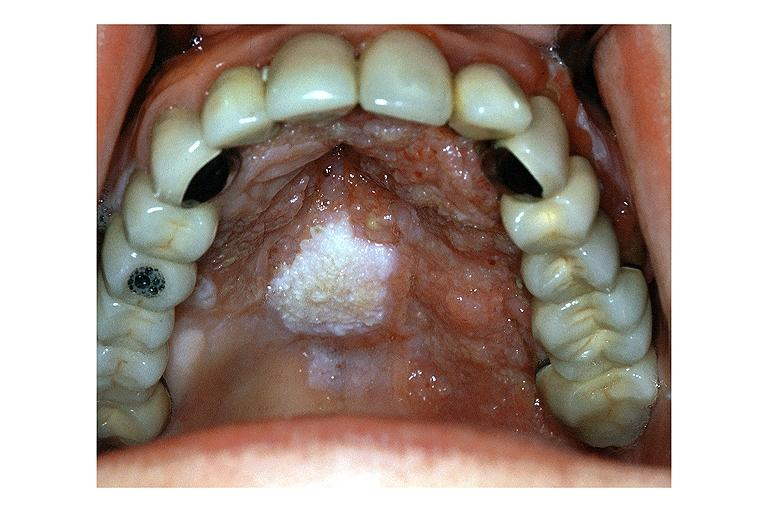where is this?
Answer the question using a single word or phrase. Oral 